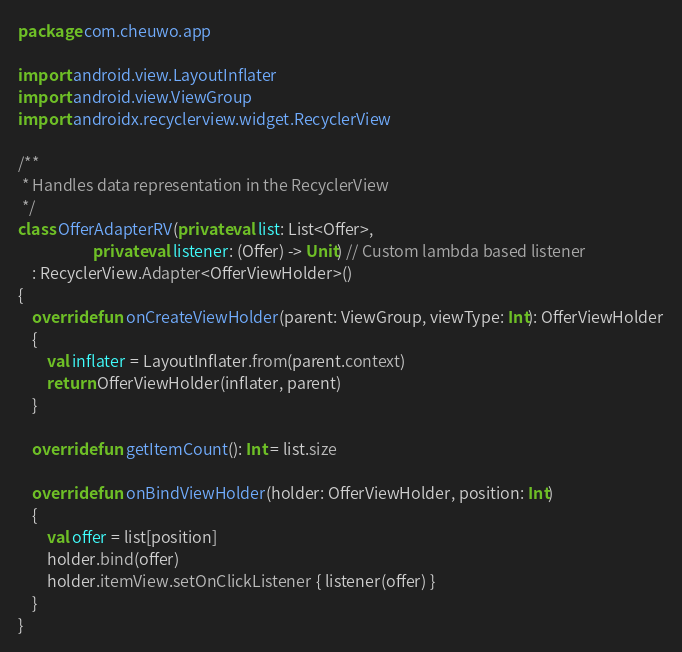<code> <loc_0><loc_0><loc_500><loc_500><_Kotlin_>package com.cheuwo.app

import android.view.LayoutInflater
import android.view.ViewGroup
import androidx.recyclerview.widget.RecyclerView

/**
 * Handles data representation in the RecyclerView
 */
class OfferAdapterRV(private val list: List<Offer>,
                     private val listener: (Offer) -> Unit) // Custom lambda based listener
    : RecyclerView.Adapter<OfferViewHolder>()
{
    override fun onCreateViewHolder(parent: ViewGroup, viewType: Int): OfferViewHolder
    {
        val inflater = LayoutInflater.from(parent.context)
        return OfferViewHolder(inflater, parent)
    }

    override fun getItemCount(): Int = list.size

    override fun onBindViewHolder(holder: OfferViewHolder, position: Int)
    {
        val offer = list[position]
        holder.bind(offer)
        holder.itemView.setOnClickListener { listener(offer) }
    }
}</code> 